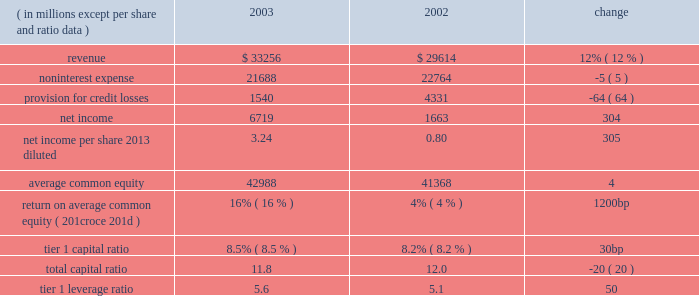Management 2019s discussion and analysis j.p .
Morgan chase & co .
22 j.p .
Morgan chase & co .
/ 2003 annual report overview j.p .
Morgan chase & co .
Is a leading global finan- cial services firm with assets of $ 771 billion and operations in more than 50 countries .
The firm serves more than 30 million consumers nationwide through its retail businesses , and many of the world's most prominent corporate , institutional and government clients through its global whole- sale businesses .
Total noninterest expense was $ 21.7 billion , down 5% ( 5 % ) from the prior year .
In 2002 , the firm recorded $ 1.3 billion of charges , princi- pally for enron-related surety litigation and the establishment of lit- igation reserves ; and $ 1.2 billion for merger and restructuring costs related to programs announced prior to january 1 , 2002 .
Excluding these costs , expenses rose by 7% ( 7 % ) in 2003 , reflecting higher per- formance-related incentives ; increased costs related to stock-based compensation and pension and other postretirement expenses ; and higher occupancy expenses .
The firm began expensing stock options in 2003 .
Restructuring costs associated with initiatives announced after january 1 , 2002 , were recorded in their relevant expense categories and totaled $ 630 million in 2003 , down 29% ( 29 % ) from 2002 .
The 2003 provision for credit losses of $ 1.5 billion was down $ 2.8 billion , or 64% ( 64 % ) , from 2002 .
The provision was lower than total net charge-offs of $ 2.3 billion , reflecting significant improvement in the quality of the commercial loan portfolio .
Commercial nonperforming assets and criticized exposure levels declined 42% ( 42 % ) and 47% ( 47 % ) , respectively , from december 31 , 2002 .
Consumer credit quality remained stable .
Earnings per diluted share ( 201ceps 201d ) for the year were $ 3.24 , an increase of 305% ( 305 % ) over the eps of $ 0.80 reported in 2002 .
Results in 2002 were provided on both a reported basis and an operating basis , which excluded merger and restructuring costs and special items .
Operating eps in 2002 was $ 1.66 .
See page 28 of this annual report for a reconciliation between reported and operating eps .
Summary of segment results the firm 2019s wholesale businesses are known globally as 201cjpmorgan , 201d and its national consumer and middle market busi- nesses are known as 201cchase . 201d the wholesale businesses com- prise four segments : the investment bank ( 201cib 201d ) , treasury & securities services ( 201ctss 201d ) , investment management & private banking ( 201cimpb 201d ) and jpmorgan partners ( 201cjpmp 201d ) .
Ib provides a full range of investment banking and commercial banking products and services , including advising on corporate strategy and structure , capital raising , risk management , and market-making in cash securities and derivative instruments in all major capital markets .
The three businesses within tss provide debt servicing , securities custody and related functions , and treasury and cash management services to corporations , financial institutions and governments .
The impb business provides invest- ment management services to institutional investors , high net worth individuals and retail customers and also provides person- alized advice and solutions to wealthy individuals and families .
Jpmp , the firm 2019s private equity business , provides equity and mez- zanine capital financing to private companies .
The firm 2019s national consumer and middle market businesses , which provide lending and full-service banking to consumers and small and middle mar- ket businesses , comprise chase financial services ( 201ccfs 201d ) .
Financial performance of jpmorgan chase as of or for the year ended december 31 .
In 2003 , global growth strengthened relative to the prior two years .
The u.s .
Economy improved significantly , supported by diminishing geopolitical uncertainties , new tax relief , strong profit growth , low interest rates and a rising stock market .
Productivity at u.s .
Businesses continued to grow at an extraor- dinary pace , as a result of ongoing investment in information technologies .
Profit margins rose to levels not seen in a long time .
New hiring remained tepid , but signs of an improving job market emerged late in the year .
Inflation fell to the lowest level in more than 40 years , and the board of governors of the federal reserve system ( the 201cfederal reserve board 201d ) declared that its long-run goal of price stability had been achieved .
Against this backdrop , j.p .
Morgan chase & co .
( 201cjpmorgan chase 201d or the 201cfirm 201d ) reported 2003 net income of $ 6.7 bil- lion , compared with net income of $ 1.7 billion in 2002 .
All five of the firm 2019s lines of business benefited from the improved eco- nomic conditions , with each reporting increased revenue over 2002 .
In particular , the low 2013interest rate environment drove robust fixed income markets and an unprecedented mortgage refinancing boom , resulting in record earnings in the investment bank and chase financial services .
Total revenue for 2003 was $ 33.3 billion , up 12% ( 12 % ) from 2002 .
The investment bank 2019s revenue increased by approximately $ 1.9 billion from 2002 , and chase financial services 2019 revenue was $ 14.6 billion in 2003 , another record year. .
What was non-interest expense as a percentage of revenue in 2003? 
Computations: (21688 / 33256)
Answer: 0.65215. 